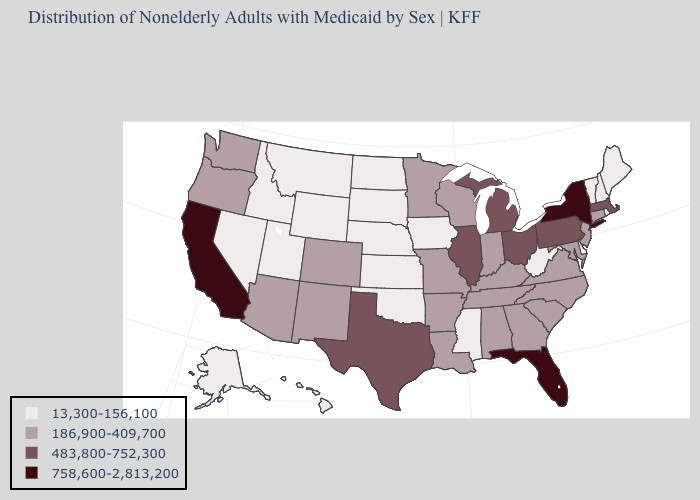What is the value of Connecticut?
Keep it brief. 186,900-409,700. Does Utah have the lowest value in the West?
Keep it brief. Yes. Name the states that have a value in the range 13,300-156,100?
Concise answer only. Alaska, Delaware, Hawaii, Idaho, Iowa, Kansas, Maine, Mississippi, Montana, Nebraska, Nevada, New Hampshire, North Dakota, Oklahoma, Rhode Island, South Dakota, Utah, Vermont, West Virginia, Wyoming. Among the states that border Minnesota , does North Dakota have the lowest value?
Answer briefly. Yes. Name the states that have a value in the range 483,800-752,300?
Write a very short answer. Illinois, Massachusetts, Michigan, Ohio, Pennsylvania, Texas. Which states hav the highest value in the South?
Quick response, please. Florida. Does Colorado have the highest value in the USA?
Give a very brief answer. No. Does Delaware have the lowest value in the South?
Write a very short answer. Yes. What is the value of New Hampshire?
Concise answer only. 13,300-156,100. Name the states that have a value in the range 186,900-409,700?
Give a very brief answer. Alabama, Arizona, Arkansas, Colorado, Connecticut, Georgia, Indiana, Kentucky, Louisiana, Maryland, Minnesota, Missouri, New Jersey, New Mexico, North Carolina, Oregon, South Carolina, Tennessee, Virginia, Washington, Wisconsin. Among the states that border Washington , which have the highest value?
Keep it brief. Oregon. Name the states that have a value in the range 758,600-2,813,200?
Short answer required. California, Florida, New York. Which states have the lowest value in the USA?
Answer briefly. Alaska, Delaware, Hawaii, Idaho, Iowa, Kansas, Maine, Mississippi, Montana, Nebraska, Nevada, New Hampshire, North Dakota, Oklahoma, Rhode Island, South Dakota, Utah, Vermont, West Virginia, Wyoming. Does Tennessee have the same value as Indiana?
Be succinct. Yes. Among the states that border Pennsylvania , does Ohio have the highest value?
Write a very short answer. No. 